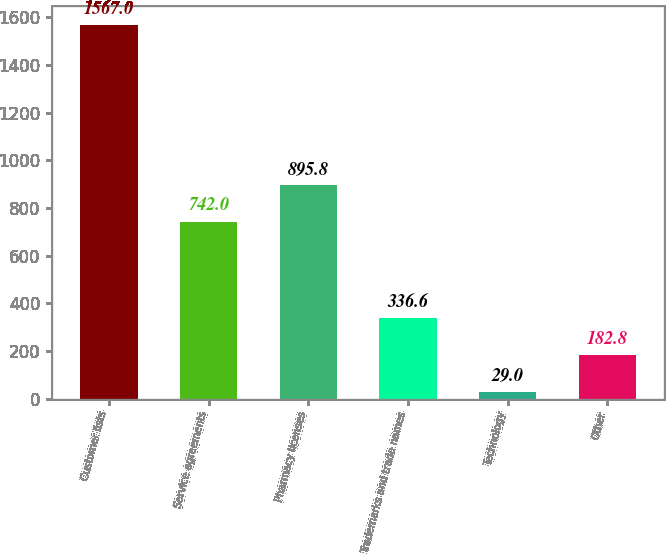<chart> <loc_0><loc_0><loc_500><loc_500><bar_chart><fcel>Customer lists<fcel>Service agreements<fcel>Pharmacy licenses<fcel>Trademarks and trade names<fcel>Technology<fcel>Other<nl><fcel>1567<fcel>742<fcel>895.8<fcel>336.6<fcel>29<fcel>182.8<nl></chart> 